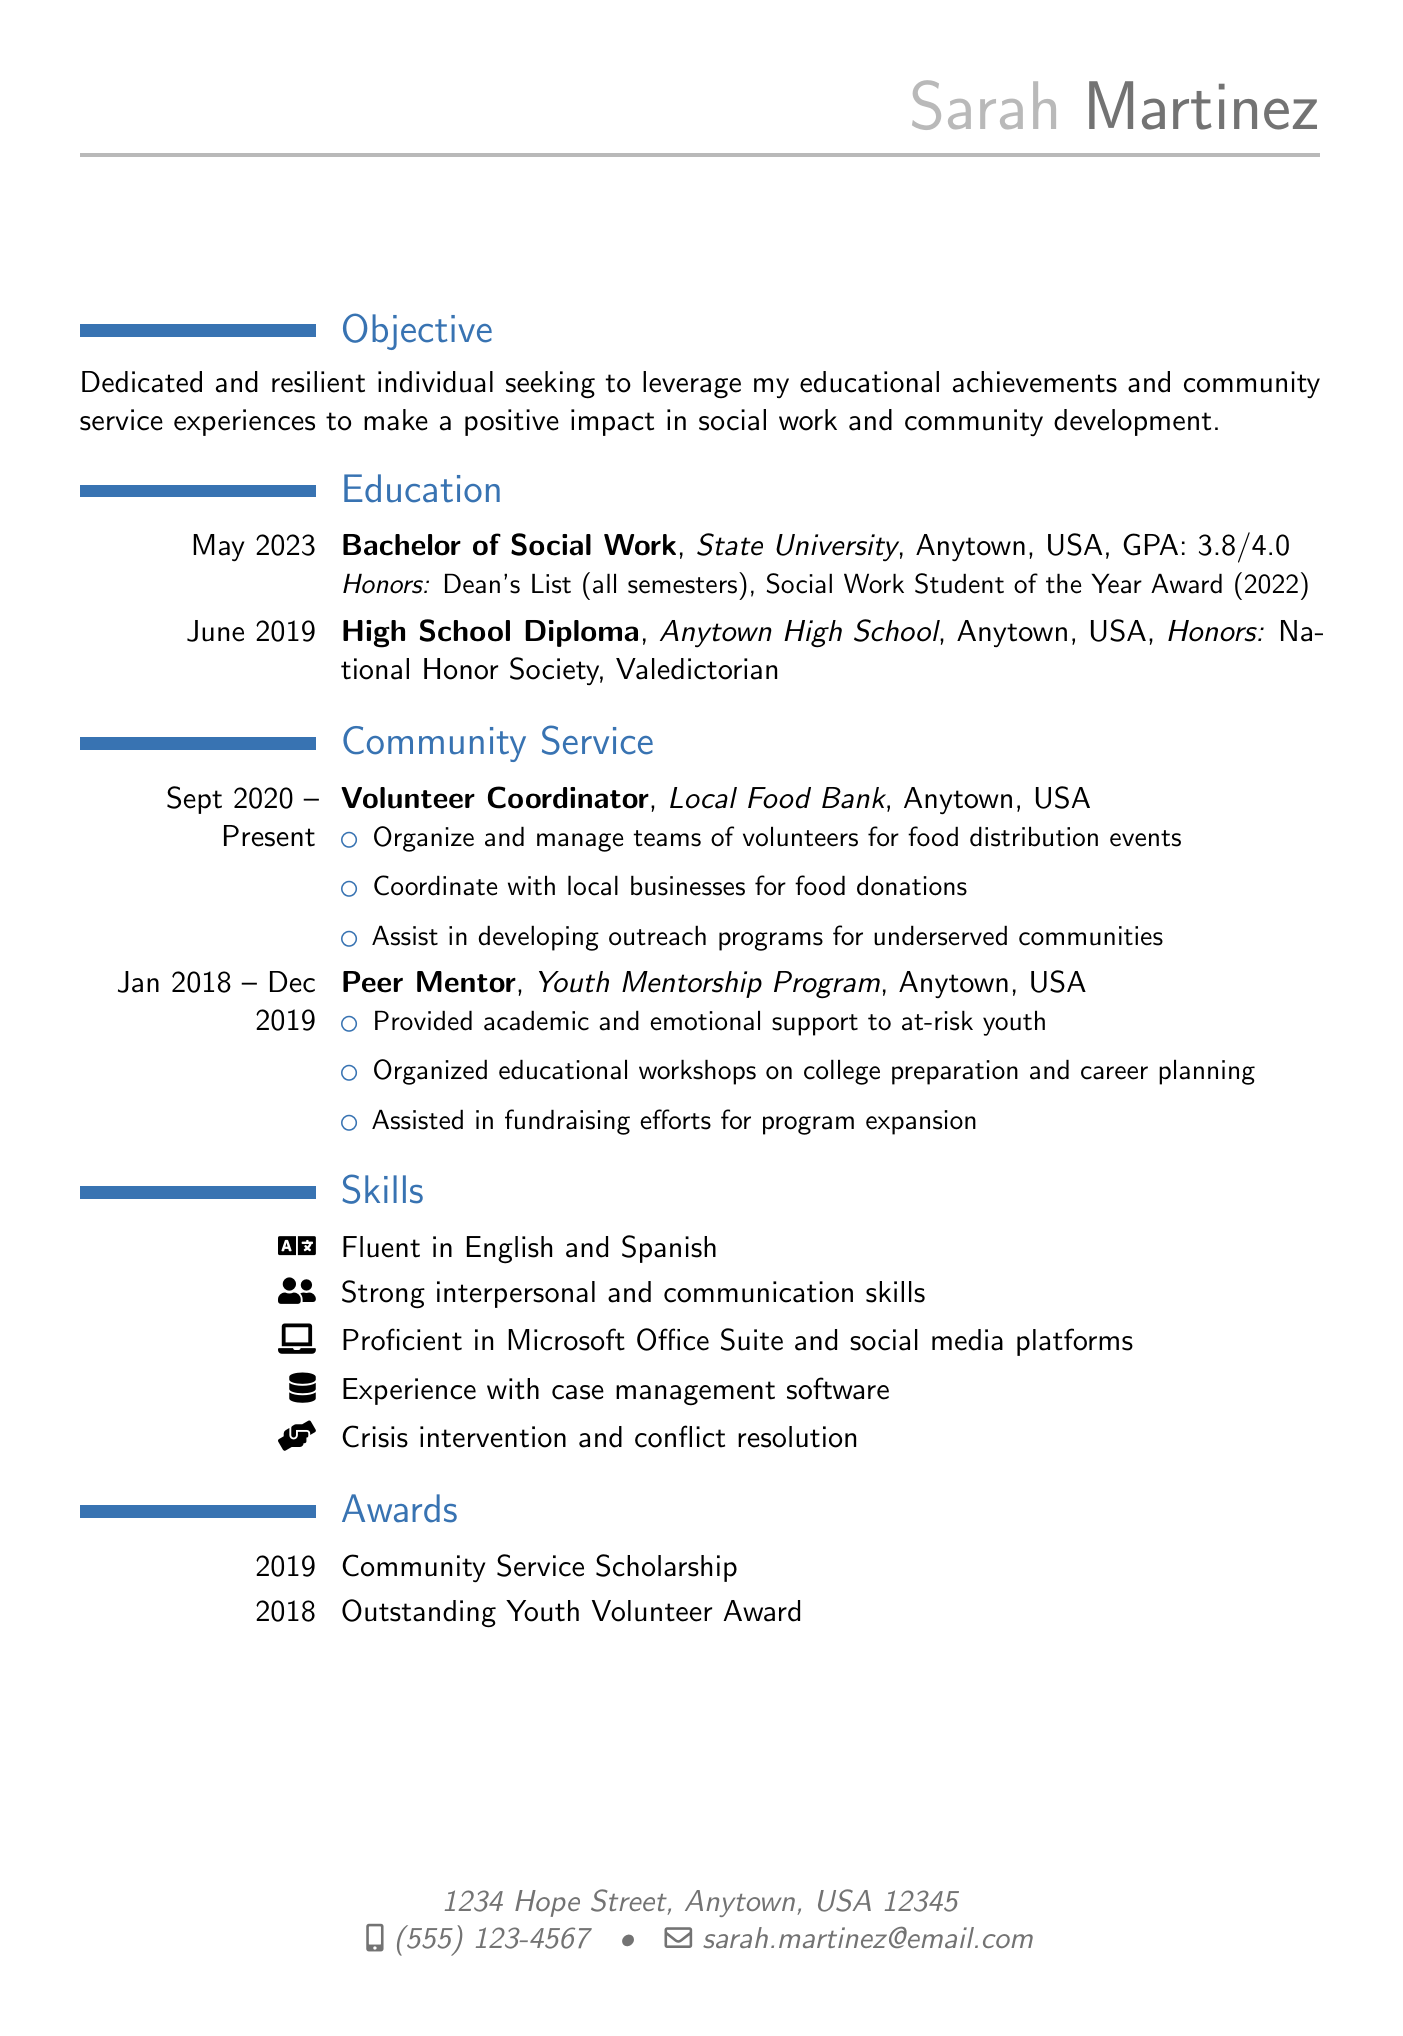What is Sarah's GPA? Sarah's GPA is mentioned under her education section for the Bachelor of Social Work.
Answer: 3.8/4.0 What degree did Sarah earn? The degree earned by Sarah is specified in the education section as a Bachelor of Social Work.
Answer: Bachelor of Social Work Which organization did Sarah serve as Volunteer Coordinator? The document specifies that Sarah served as a Volunteer Coordinator for the Local Food Bank.
Answer: Local Food Bank In what year did Sarah graduate from high school? The graduation date for Sarah's high school diploma is provided in the education section.
Answer: June 2019 What award did Sarah receive in 2022? The resume details the Social Work Student of the Year Award received by Sarah in 2022.
Answer: Social Work Student of the Year Award How many years did Sarah work as a Peer Mentor? The dates listed for her role as a Peer Mentor indicate a span from January 2018 to December 2019.
Answer: 2 years What languages is Sarah fluent in? The skills section lists the languages in which Sarah is fluent.
Answer: English and Spanish What is Sarah's volunteer position at the Local Food Bank? The role at the Local Food Bank is specified as Volunteer Coordinator in the community service section.
Answer: Volunteer Coordinator Which high school honor was Sarah awarded? The education section highlights multiple honors, one of which is the National Honor Society.
Answer: National Honor Society 